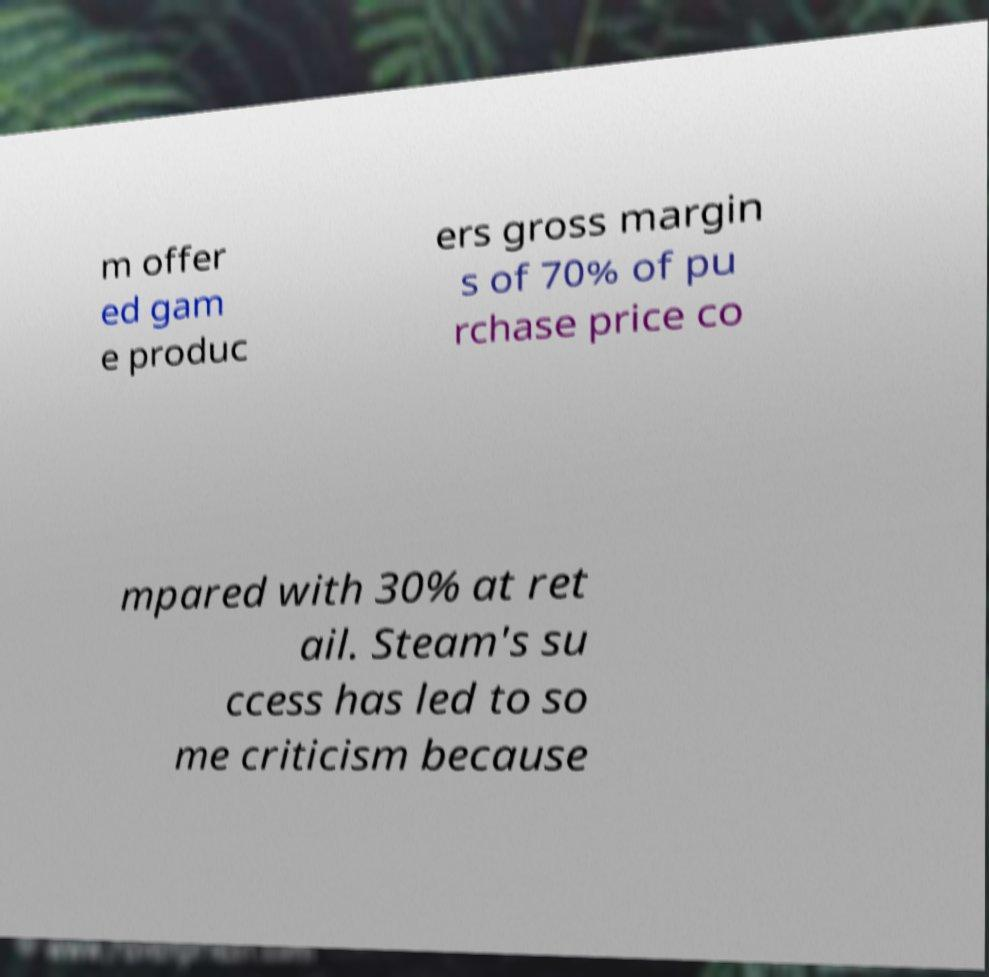What messages or text are displayed in this image? I need them in a readable, typed format. m offer ed gam e produc ers gross margin s of 70% of pu rchase price co mpared with 30% at ret ail. Steam's su ccess has led to so me criticism because 